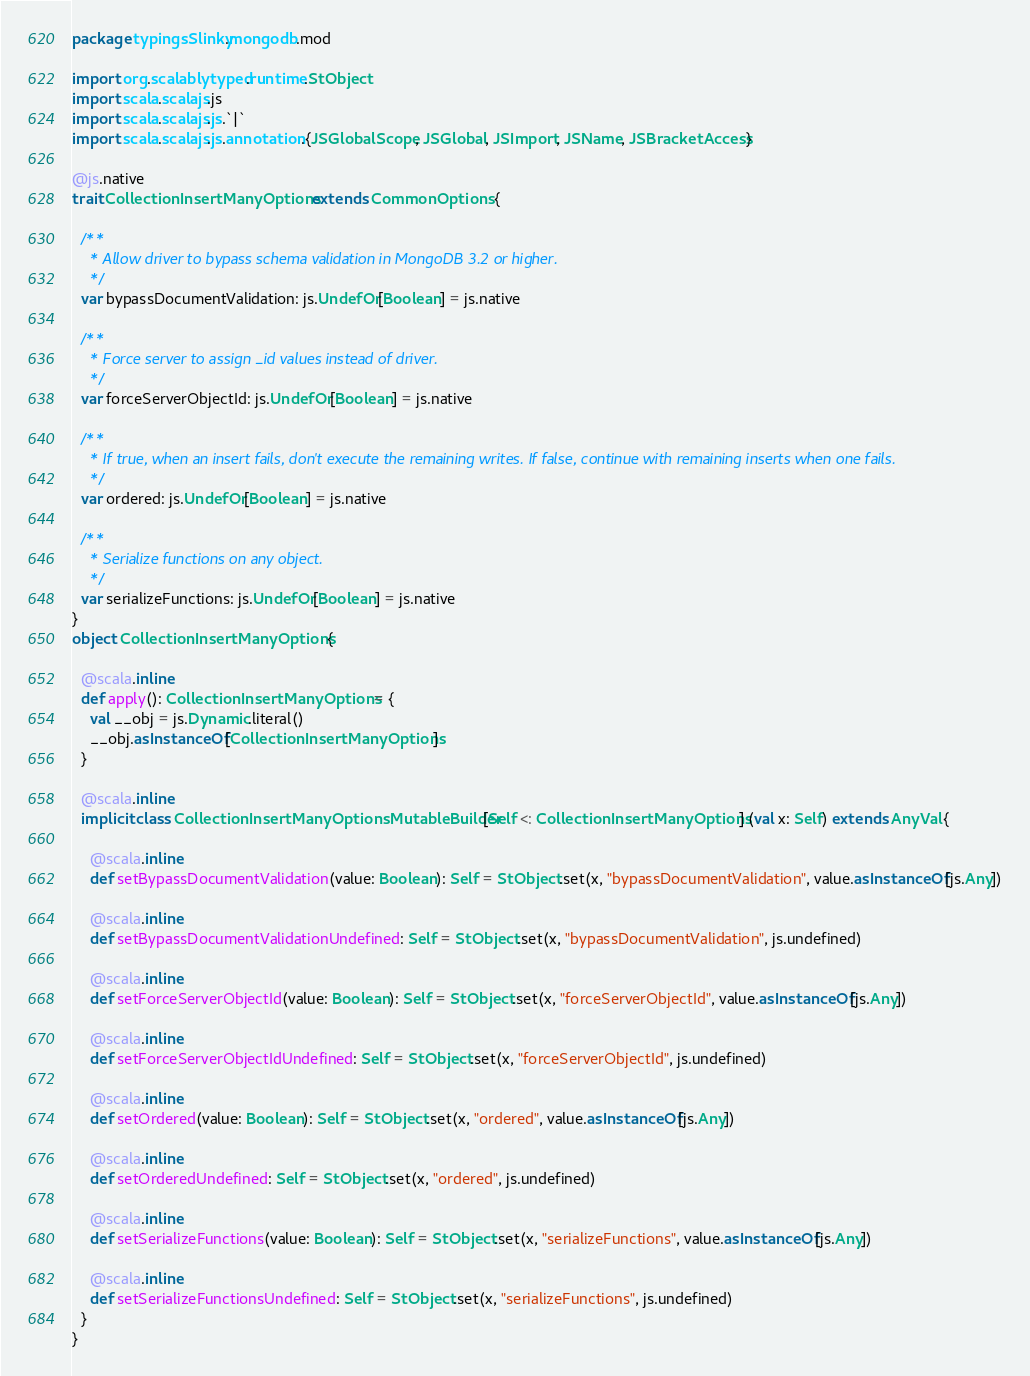Convert code to text. <code><loc_0><loc_0><loc_500><loc_500><_Scala_>package typingsSlinky.mongodb.mod

import org.scalablytyped.runtime.StObject
import scala.scalajs.js
import scala.scalajs.js.`|`
import scala.scalajs.js.annotation.{JSGlobalScope, JSGlobal, JSImport, JSName, JSBracketAccess}

@js.native
trait CollectionInsertManyOptions extends CommonOptions {
  
  /**
    * Allow driver to bypass schema validation in MongoDB 3.2 or higher.
    */
  var bypassDocumentValidation: js.UndefOr[Boolean] = js.native
  
  /**
    * Force server to assign _id values instead of driver.
    */
  var forceServerObjectId: js.UndefOr[Boolean] = js.native
  
  /**
    * If true, when an insert fails, don't execute the remaining writes. If false, continue with remaining inserts when one fails.
    */
  var ordered: js.UndefOr[Boolean] = js.native
  
  /**
    * Serialize functions on any object.
    */
  var serializeFunctions: js.UndefOr[Boolean] = js.native
}
object CollectionInsertManyOptions {
  
  @scala.inline
  def apply(): CollectionInsertManyOptions = {
    val __obj = js.Dynamic.literal()
    __obj.asInstanceOf[CollectionInsertManyOptions]
  }
  
  @scala.inline
  implicit class CollectionInsertManyOptionsMutableBuilder[Self <: CollectionInsertManyOptions] (val x: Self) extends AnyVal {
    
    @scala.inline
    def setBypassDocumentValidation(value: Boolean): Self = StObject.set(x, "bypassDocumentValidation", value.asInstanceOf[js.Any])
    
    @scala.inline
    def setBypassDocumentValidationUndefined: Self = StObject.set(x, "bypassDocumentValidation", js.undefined)
    
    @scala.inline
    def setForceServerObjectId(value: Boolean): Self = StObject.set(x, "forceServerObjectId", value.asInstanceOf[js.Any])
    
    @scala.inline
    def setForceServerObjectIdUndefined: Self = StObject.set(x, "forceServerObjectId", js.undefined)
    
    @scala.inline
    def setOrdered(value: Boolean): Self = StObject.set(x, "ordered", value.asInstanceOf[js.Any])
    
    @scala.inline
    def setOrderedUndefined: Self = StObject.set(x, "ordered", js.undefined)
    
    @scala.inline
    def setSerializeFunctions(value: Boolean): Self = StObject.set(x, "serializeFunctions", value.asInstanceOf[js.Any])
    
    @scala.inline
    def setSerializeFunctionsUndefined: Self = StObject.set(x, "serializeFunctions", js.undefined)
  }
}
</code> 